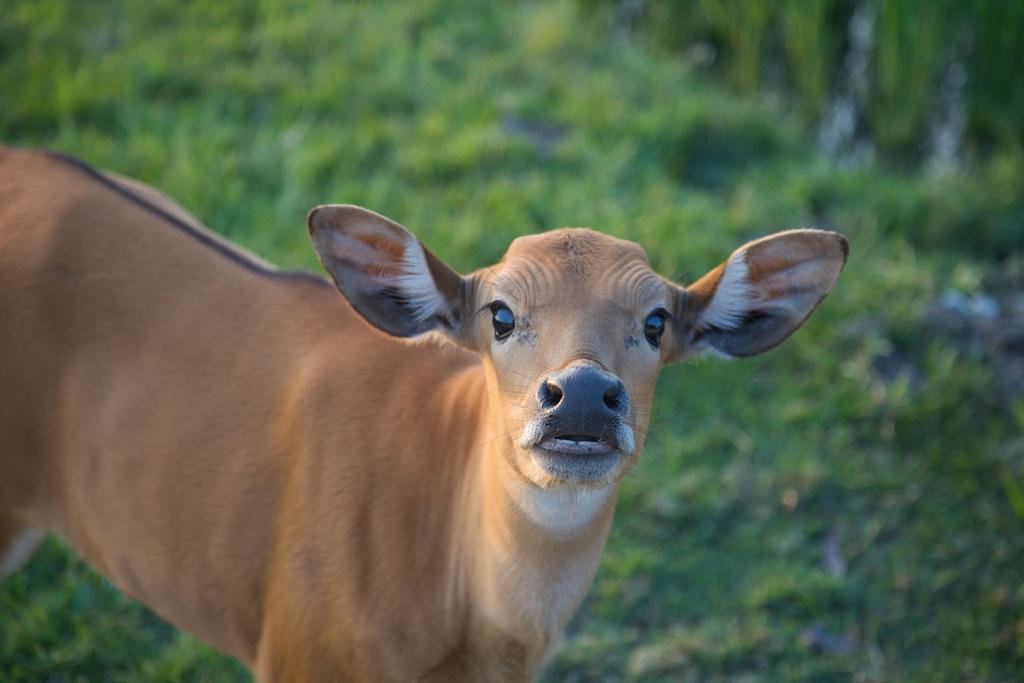How would you summarize this image in a sentence or two? In the center of the image we can see cow. In the background there is grass. 